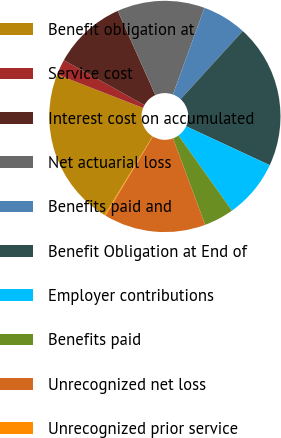Convert chart. <chart><loc_0><loc_0><loc_500><loc_500><pie_chart><fcel>Benefit obligation at<fcel>Service cost<fcel>Interest cost on accumulated<fcel>Net actuarial loss<fcel>Benefits paid and<fcel>Benefit Obligation at End of<fcel>Employer contributions<fcel>Benefits paid<fcel>Unrecognized net loss<fcel>Unrecognized prior service<nl><fcel>22.17%<fcel>2.17%<fcel>10.23%<fcel>12.25%<fcel>6.2%<fcel>20.16%<fcel>8.22%<fcel>4.19%<fcel>14.26%<fcel>0.15%<nl></chart> 